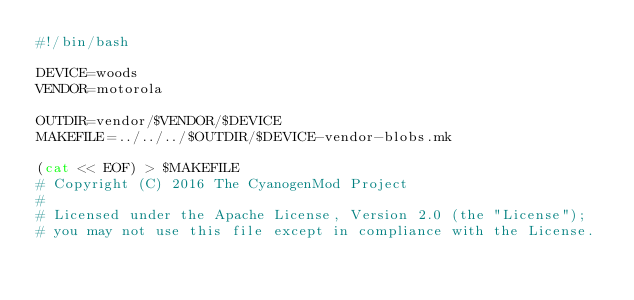<code> <loc_0><loc_0><loc_500><loc_500><_Bash_>#!/bin/bash

DEVICE=woods
VENDOR=motorola

OUTDIR=vendor/$VENDOR/$DEVICE
MAKEFILE=../../../$OUTDIR/$DEVICE-vendor-blobs.mk

(cat << EOF) > $MAKEFILE
# Copyright (C) 2016 The CyanogenMod Project
#
# Licensed under the Apache License, Version 2.0 (the "License");
# you may not use this file except in compliance with the License.</code> 